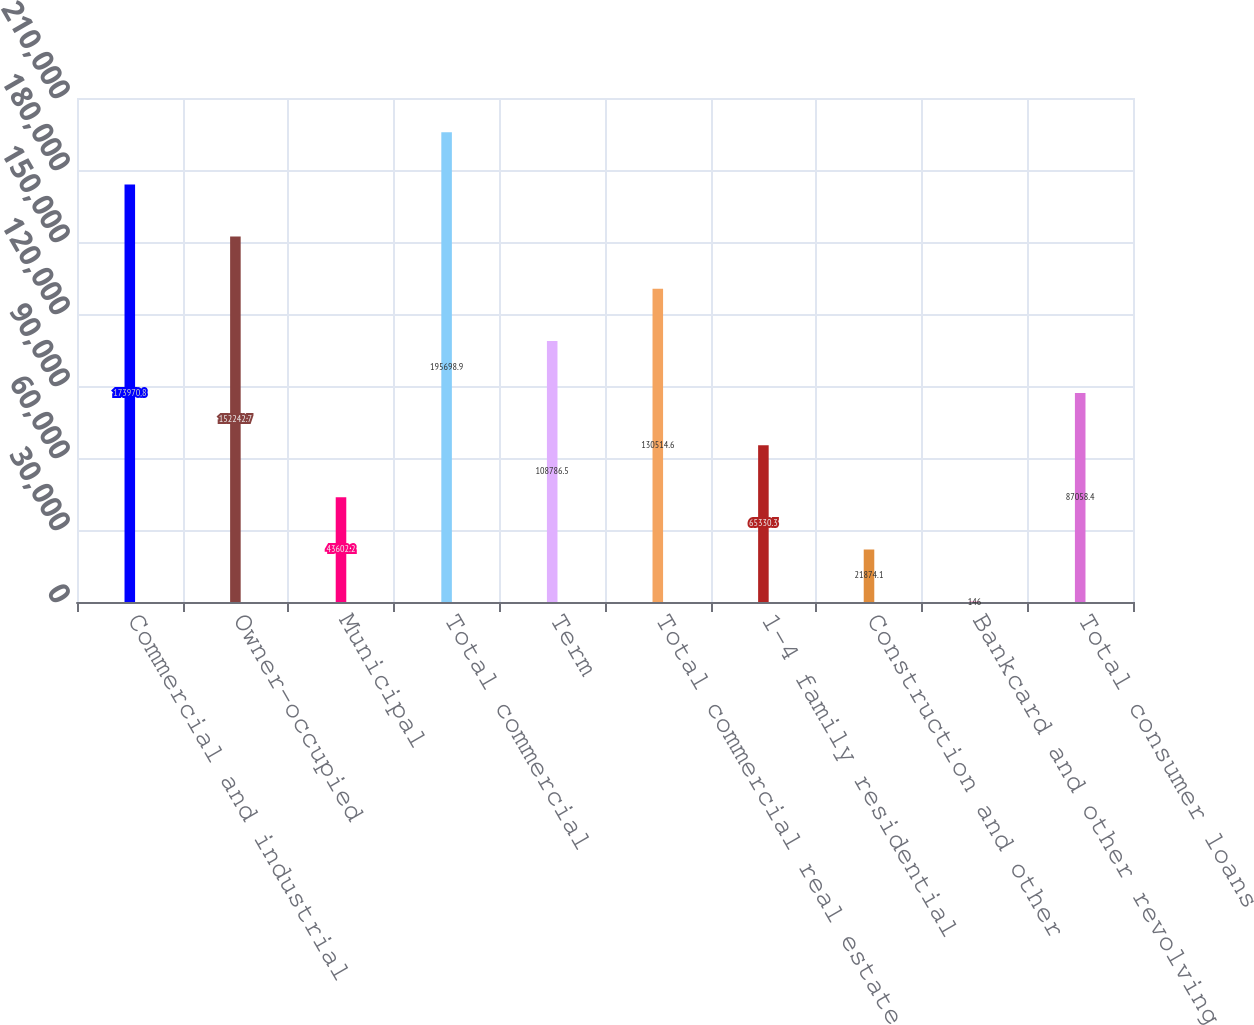Convert chart. <chart><loc_0><loc_0><loc_500><loc_500><bar_chart><fcel>Commercial and industrial<fcel>Owner-occupied<fcel>Municipal<fcel>Total commercial<fcel>Term<fcel>Total commercial real estate<fcel>1-4 family residential<fcel>Construction and other<fcel>Bankcard and other revolving<fcel>Total consumer loans<nl><fcel>173971<fcel>152243<fcel>43602.2<fcel>195699<fcel>108786<fcel>130515<fcel>65330.3<fcel>21874.1<fcel>146<fcel>87058.4<nl></chart> 